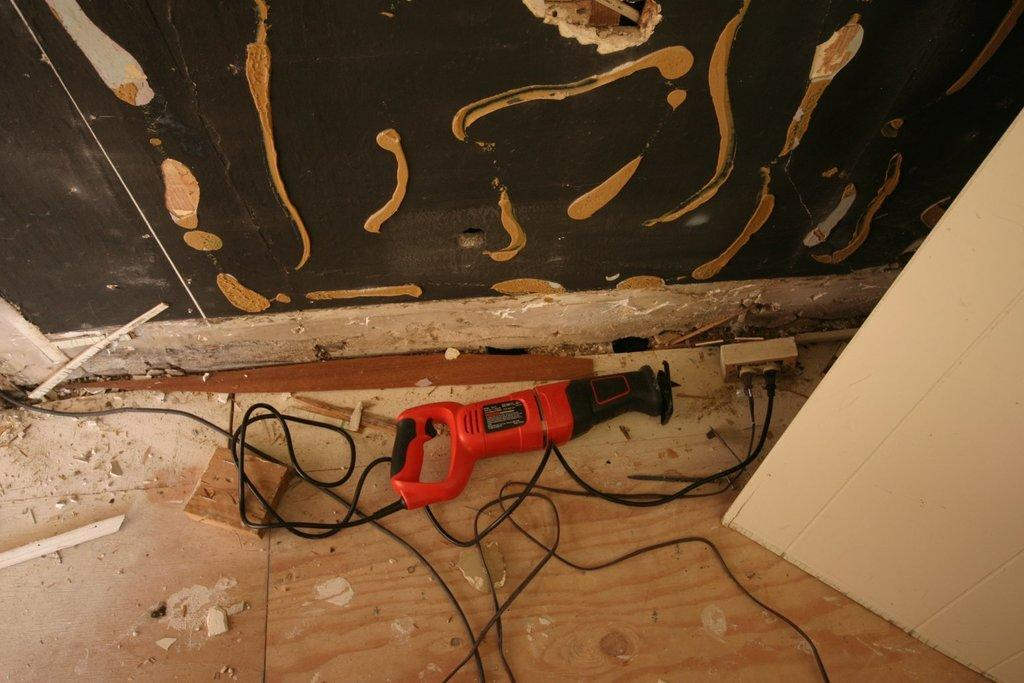What is located in the foreground of the image? There is a machine, a wire, and a switchboard in the foreground of the image. Can you describe the wire in the foreground? Yes, there is a wire in the foreground of the image. What is visible on the top of the image? There is cardboard visible on the top of the image. Where is the cardboard located on the right side of the image? There is a cardboard box on the right side of the image. How many thumbs are resting on the machine in the image? There are no thumbs visible in the image, and no one is resting on the machine. Can you smell the rose in the image? There is no rose present in the image, so it cannot be smelled. 